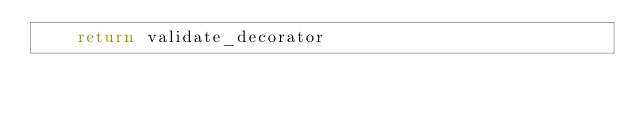<code> <loc_0><loc_0><loc_500><loc_500><_Python_>    return validate_decorator
</code> 